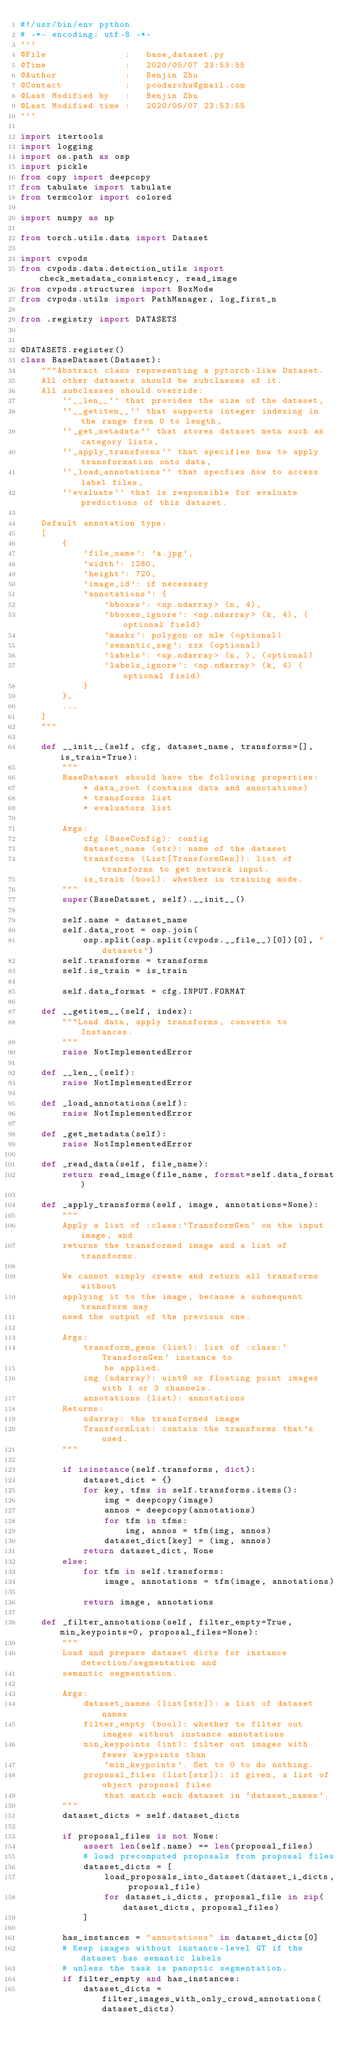Convert code to text. <code><loc_0><loc_0><loc_500><loc_500><_Python_>#!/usr/bin/env python
# -*- encoding: utf-8 -*-
'''
@File               :   base_dataset.py
@Time               :   2020/05/07 23:53:55
@Author             :   Benjin Zhu
@Contact            :   poodarchu@gmail.com
@Last Modified by   :   Benjin Zhu
@Last Modified time :   2020/05/07 23:53:55
'''

import itertools
import logging
import os.path as osp
import pickle
from copy import deepcopy
from tabulate import tabulate
from termcolor import colored

import numpy as np

from torch.utils.data import Dataset

import cvpods
from cvpods.data.detection_utils import check_metadata_consistency, read_image
from cvpods.structures import BoxMode
from cvpods.utils import PathManager, log_first_n

from .registry import DATASETS


@DATASETS.register()
class BaseDataset(Dataset):
    """Abstract class representing a pytorch-like Dataset.
    All other datasets should be subclasses of it.
    All subclasses should override:
        ``__len__`` that provides the size of the dataset,
        ``__getitem__`` that supports integer indexing in the range from 0 to length,
        ``_get_metadata`` that stores dataset meta such as category lists,
        ``_apply_transforms`` that specifies how to apply transformation onto data,
        ``_load_annotations`` that specfies how to access label files,
        ``evaluate`` that is responsible for evaluate predictions of this dataset.

    Default annotation type:
    [
        {
            'file_name': 'a.jpg',
            'width': 1280,
            'height': 720,
            'image_id': if necessary
            'annotations': {
                'bboxes': <np.ndarray> (n, 4),
                'bboxes_ignore': <np.ndarray> (k, 4), (optional field)
                'masks': polygon or mle (optional)
                'semantic_seg': xxx (optional)
                'labels': <np.ndarray> (n, ), (optional)
                'labels_ignore': <np.ndarray> (k, 4) (optional field)
            }
        },
        ...
    ]
    """

    def __init__(self, cfg, dataset_name, transforms=[], is_train=True):
        """
        BaseDataset should have the following properties:
            * data_root (contains data and annotations)
            * transforms list
            * evaluators list

        Args:
            cfg (BaseConfig): config
            dataset_name (str): name of the dataset
            transforms (List[TransformGen]): list of transforms to get network input.
            is_train (bool): whether in training mode.
        """
        super(BaseDataset, self).__init__()

        self.name = dataset_name
        self.data_root = osp.join(
            osp.split(osp.split(cvpods.__file__)[0])[0], "datasets")
        self.transforms = transforms
        self.is_train = is_train

        self.data_format = cfg.INPUT.FORMAT

    def __getitem__(self, index):
        """Load data, apply transforms, converto to Instances.
        """
        raise NotImplementedError

    def __len__(self):
        raise NotImplementedError

    def _load_annotations(self):
        raise NotImplementedError

    def _get_metadata(self):
        raise NotImplementedError

    def _read_data(self, file_name):
        return read_image(file_name, format=self.data_format)

    def _apply_transforms(self, image, annotations=None):
        """
        Apply a list of :class:`TransformGen` on the input image, and
        returns the transformed image and a list of transforms.

        We cannot simply create and return all transforms without
        applying it to the image, because a subsequent transform may
        need the output of the previous one.

        Args:
            transform_gens (list): list of :class:`TransformGen` instance to
                be applied.
            img (ndarray): uint8 or floating point images with 1 or 3 channels.
            annotations (list): annotations
        Returns:
            ndarray: the transformed image
            TransformList: contain the transforms that's used.
        """

        if isinstance(self.transforms, dict):
            dataset_dict = {}
            for key, tfms in self.transforms.items():
                img = deepcopy(image)
                annos = deepcopy(annotations)
                for tfm in tfms:
                    img, annos = tfm(img, annos)
                dataset_dict[key] = (img, annos)
            return dataset_dict, None
        else:
            for tfm in self.transforms:
                image, annotations = tfm(image, annotations)

            return image, annotations

    def _filter_annotations(self, filter_empty=True, min_keypoints=0, proposal_files=None):
        """
        Load and prepare dataset dicts for instance detection/segmentation and
        semantic segmentation.

        Args:
            dataset_names (list[str]): a list of dataset names
            filter_empty (bool): whether to filter out images without instance annotations
            min_keypoints (int): filter out images with fewer keypoints than
                `min_keypoints`. Set to 0 to do nothing.
            proposal_files (list[str]): if given, a list of object proposal files
                that match each dataset in `dataset_names`.
        """
        dataset_dicts = self.dataset_dicts

        if proposal_files is not None:
            assert len(self.name) == len(proposal_files)
            # load precomputed proposals from proposal files
            dataset_dicts = [
                load_proposals_into_dataset(dataset_i_dicts, proposal_file)
                for dataset_i_dicts, proposal_file in zip(dataset_dicts, proposal_files)
            ]

        has_instances = "annotations" in dataset_dicts[0]
        # Keep images without instance-level GT if the dataset has semantic labels
        # unless the task is panoptic segmentation.
        if filter_empty and has_instances:
            dataset_dicts = filter_images_with_only_crowd_annotations(dataset_dicts)
</code> 